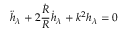Convert formula to latex. <formula><loc_0><loc_0><loc_500><loc_500>\ddot { h } _ { \lambda } + 2 { \frac { \dot { R } } { R } } \dot { h } _ { \lambda } + k ^ { 2 } h _ { \lambda } = 0</formula> 